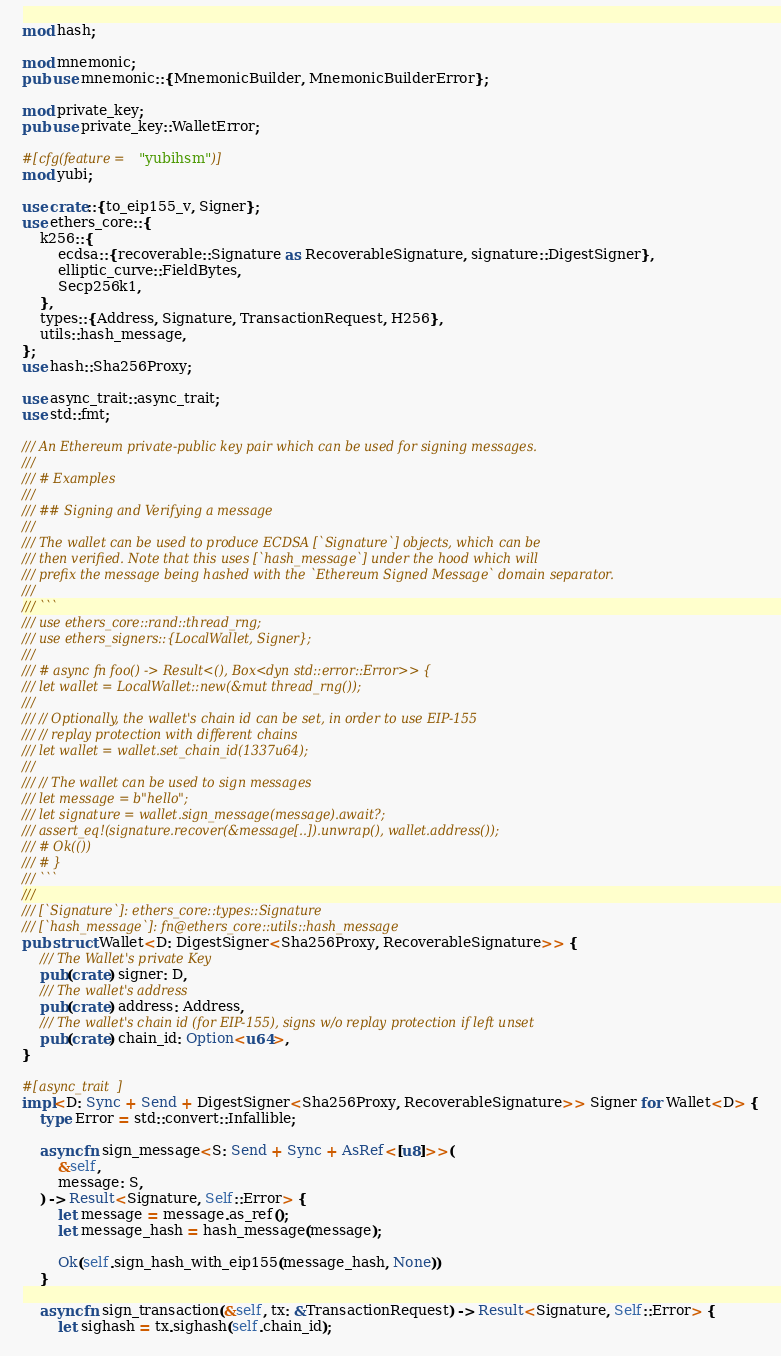<code> <loc_0><loc_0><loc_500><loc_500><_Rust_>mod hash;

mod mnemonic;
pub use mnemonic::{MnemonicBuilder, MnemonicBuilderError};

mod private_key;
pub use private_key::WalletError;

#[cfg(feature = "yubihsm")]
mod yubi;

use crate::{to_eip155_v, Signer};
use ethers_core::{
    k256::{
        ecdsa::{recoverable::Signature as RecoverableSignature, signature::DigestSigner},
        elliptic_curve::FieldBytes,
        Secp256k1,
    },
    types::{Address, Signature, TransactionRequest, H256},
    utils::hash_message,
};
use hash::Sha256Proxy;

use async_trait::async_trait;
use std::fmt;

/// An Ethereum private-public key pair which can be used for signing messages.
///
/// # Examples
///
/// ## Signing and Verifying a message
///
/// The wallet can be used to produce ECDSA [`Signature`] objects, which can be
/// then verified. Note that this uses [`hash_message`] under the hood which will
/// prefix the message being hashed with the `Ethereum Signed Message` domain separator.
///
/// ```
/// use ethers_core::rand::thread_rng;
/// use ethers_signers::{LocalWallet, Signer};
///
/// # async fn foo() -> Result<(), Box<dyn std::error::Error>> {
/// let wallet = LocalWallet::new(&mut thread_rng());
///
/// // Optionally, the wallet's chain id can be set, in order to use EIP-155
/// // replay protection with different chains
/// let wallet = wallet.set_chain_id(1337u64);
///
/// // The wallet can be used to sign messages
/// let message = b"hello";
/// let signature = wallet.sign_message(message).await?;
/// assert_eq!(signature.recover(&message[..]).unwrap(), wallet.address());
/// # Ok(())
/// # }
/// ```
///
/// [`Signature`]: ethers_core::types::Signature
/// [`hash_message`]: fn@ethers_core::utils::hash_message
pub struct Wallet<D: DigestSigner<Sha256Proxy, RecoverableSignature>> {
    /// The Wallet's private Key
    pub(crate) signer: D,
    /// The wallet's address
    pub(crate) address: Address,
    /// The wallet's chain id (for EIP-155), signs w/o replay protection if left unset
    pub(crate) chain_id: Option<u64>,
}

#[async_trait]
impl<D: Sync + Send + DigestSigner<Sha256Proxy, RecoverableSignature>> Signer for Wallet<D> {
    type Error = std::convert::Infallible;

    async fn sign_message<S: Send + Sync + AsRef<[u8]>>(
        &self,
        message: S,
    ) -> Result<Signature, Self::Error> {
        let message = message.as_ref();
        let message_hash = hash_message(message);

        Ok(self.sign_hash_with_eip155(message_hash, None))
    }

    async fn sign_transaction(&self, tx: &TransactionRequest) -> Result<Signature, Self::Error> {
        let sighash = tx.sighash(self.chain_id);</code> 